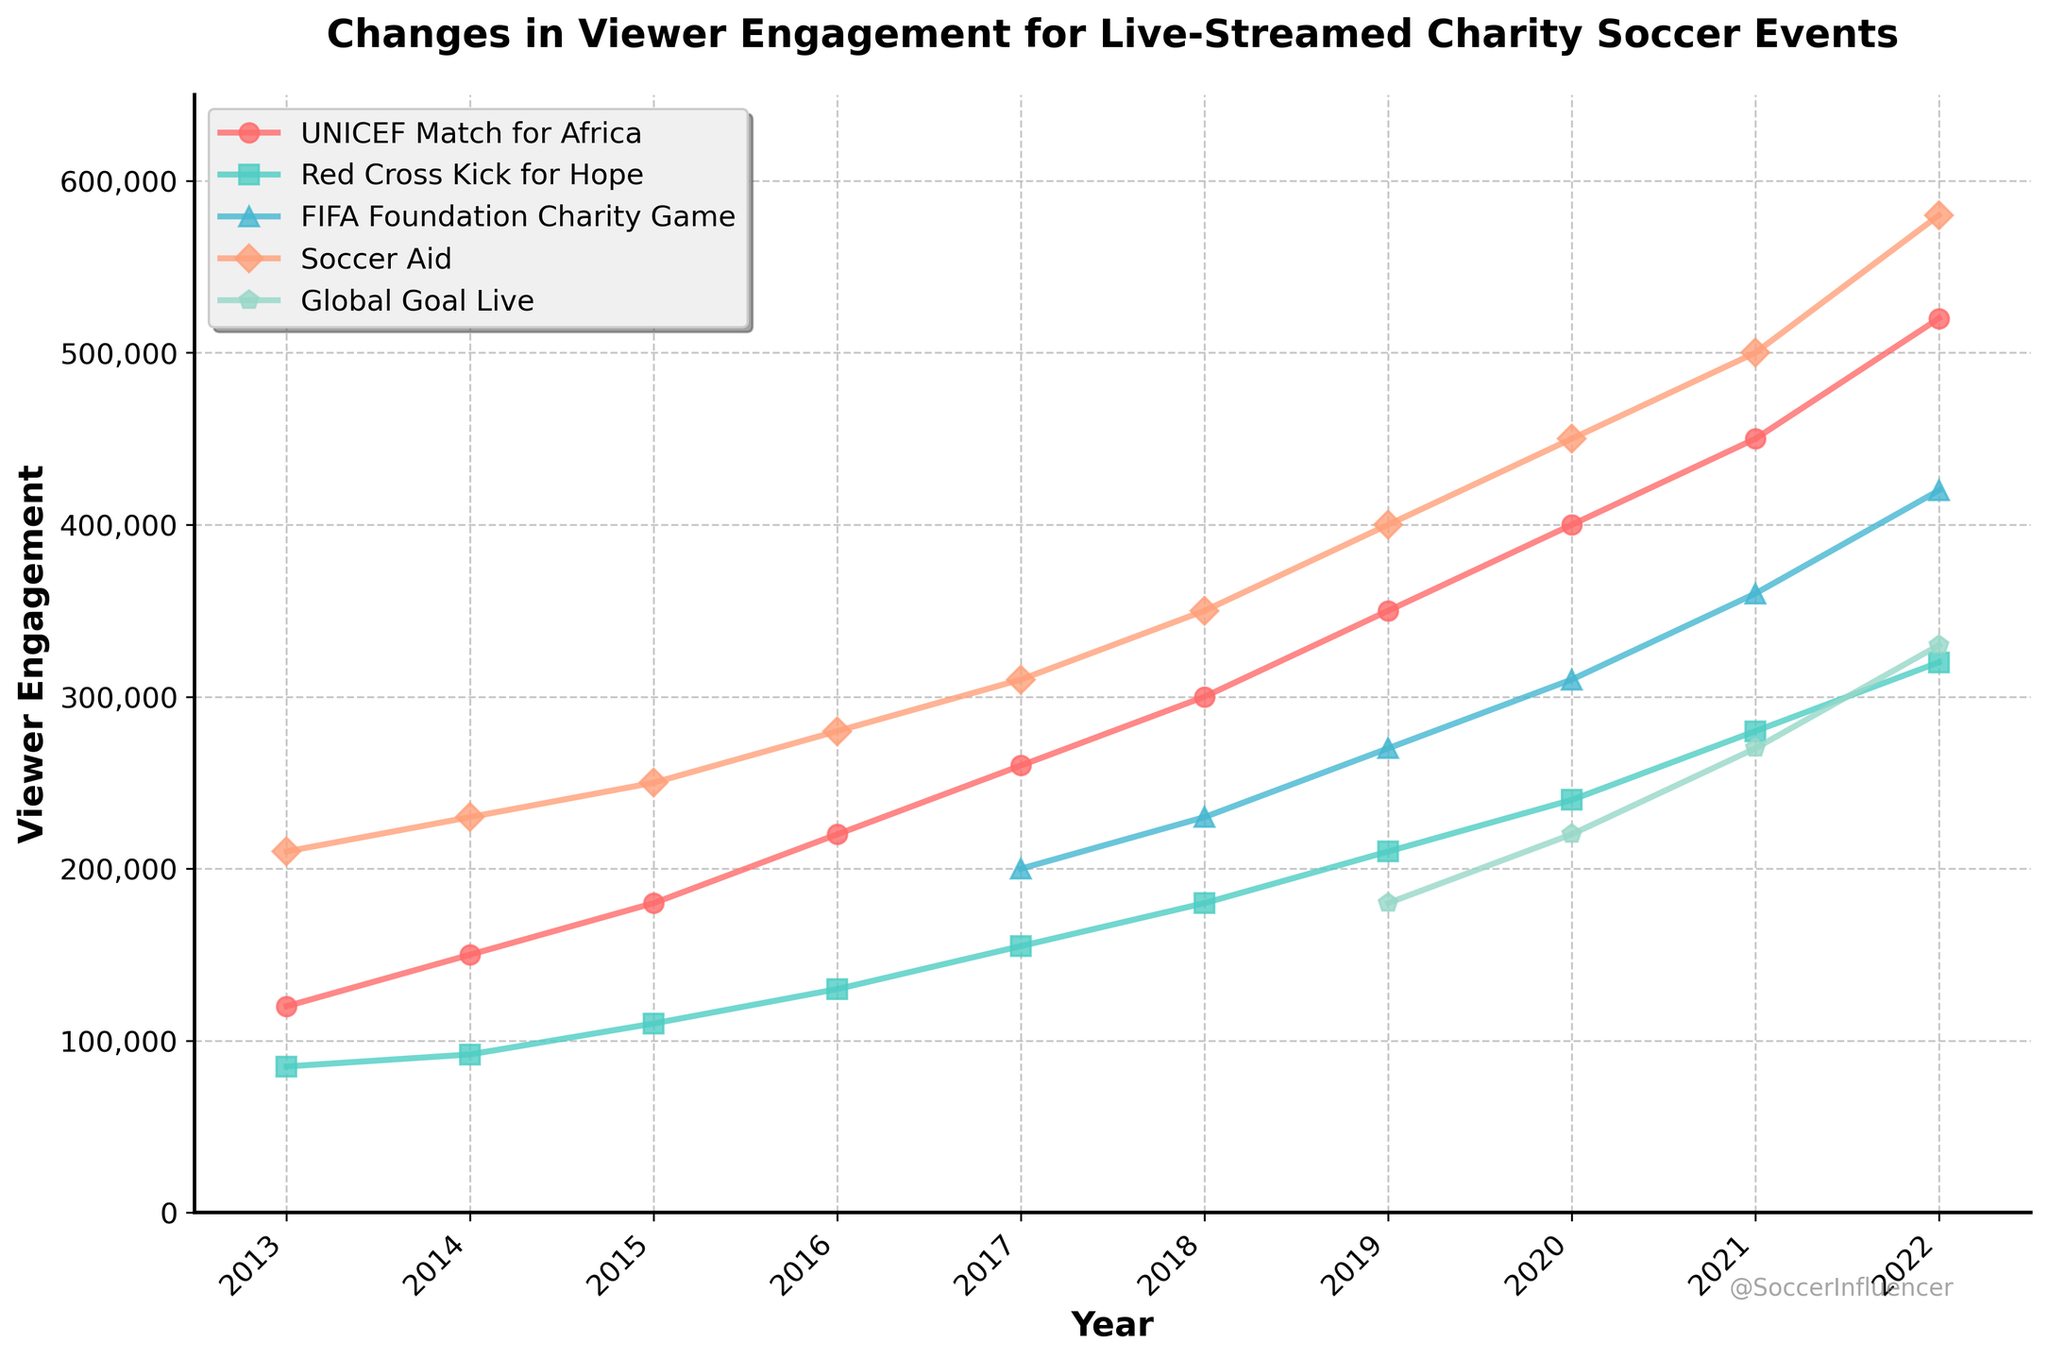What's the general trend in viewer engagement for Soccer Aid from 2013 to 2022? To find the general trend, observe the line representing Soccer Aid over the years. The line increases steadily from 210,000 in 2013 to 580,000 in 2022, indicating a consistent upward trend.
Answer: Consistent upward trend Which event had the highest viewer engagement in 2022? To determine the highest viewer engagement in 2022, look for the highest point at the right end of the lines. The line representing Soccer Aid reaches up to 580,000, which is the highest among all events in 2022.
Answer: Soccer Aid What was the viewer engagement difference between UNICEF Match for Africa and Soccer Aid in 2016? To find the difference, subtract the viewer engagement of UNICEF Match for Africa from that of Soccer Aid in 2016. Soccer Aid had 280,000 viewers, while UNICEF Match for Africa had 220,000. Thus, the difference is 280,000 - 220,000 = 60,000.
Answer: 60,000 How did the viewer engagement for Global Goal Live change from 2019 to 2022? Check the values for Global Goal Live in 2019 and 2022. In 2019, it was 180,000, and it increased to 330,000 in 2022. The change is 330,000 - 180,000 = 150,000.
Answer: Increased by 150,000 Among the events, which had no data available until 2019? Look at the lines starting or having "N/A" entries in the table before 2019. The line for Global Goal Live and FIFA Foundation Charity Game shows "N/A" until 2019.
Answer: Global Goal Live, FIFA Foundation Charity Game Compared to Red Cross Kick for Hope, which event consistently shows higher viewer engagement from 2013 to 2022? Compare the Red Cross Kick for Hope line to other lines over the entire period. The lines for UNICEF Match for Africa, Soccer Aid, and in later years Global Goal Live, are higher. The most consistent and clearly higher line is Soccer Aid.
Answer: Soccer Aid What is the average viewer engagement for UNICEF Match for Africa from 2013 to 2022? Add the values for UNICEF Match for Africa over all the years and divide by the number of years. (120,000 + 150,000 + 180,000 + 220,000 + 260,000 + 300,000 + 350,000 + 400,000 + 450,000 + 520,000) / 10 = 295,000
Answer: 295,000 Which event showed a sharp increase around 2019? Identify the event with a significant upward slope around 2019. The line for FIFA Foundation Charity Game shows a significant increase around 2019, from about 270,000 to 420,000 by 2022.
Answer: FIFA Foundation Charity Game Calculate the total viewership for Red Cross Kick for Hope over the decade. Sum the values for Red Cross Kick for Hope from 2013 to 2022. 85,000 + 92,000 + 110,000 + 130,000 + 155,000 + 180,000 + 210,000 + 240,000 + 280,000 + 320,000 = 1,802,000
Answer: 1,802,000 